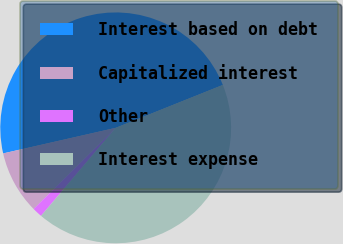Convert chart. <chart><loc_0><loc_0><loc_500><loc_500><pie_chart><fcel>Interest based on debt<fcel>Capitalized interest<fcel>Other<fcel>Interest expense<nl><fcel>47.5%<fcel>8.85%<fcel>1.4%<fcel>42.26%<nl></chart> 